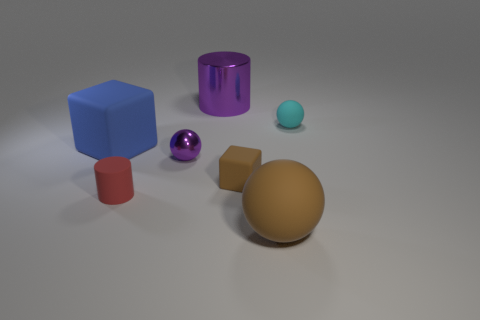Is the color of the big ball the same as the large metallic cylinder?
Make the answer very short. No. Does the block on the right side of the blue cube have the same material as the block that is to the left of the big purple thing?
Keep it short and to the point. Yes. There is a thing that is the same color as the small cube; what size is it?
Give a very brief answer. Large. There is a purple object in front of the tiny rubber sphere; what is it made of?
Keep it short and to the point. Metal. Do the purple metal thing that is behind the big rubber block and the thing that is on the right side of the brown sphere have the same shape?
Your response must be concise. No. There is a small object that is the same color as the large cylinder; what is its material?
Ensure brevity in your answer.  Metal. Are there any large brown balls?
Provide a succinct answer. Yes. There is another large thing that is the same shape as the red rubber object; what is it made of?
Provide a short and direct response. Metal. Are there any tiny brown matte blocks in front of the big brown thing?
Your response must be concise. No. Are the tiny thing on the right side of the large brown ball and the small brown cube made of the same material?
Your response must be concise. Yes. 